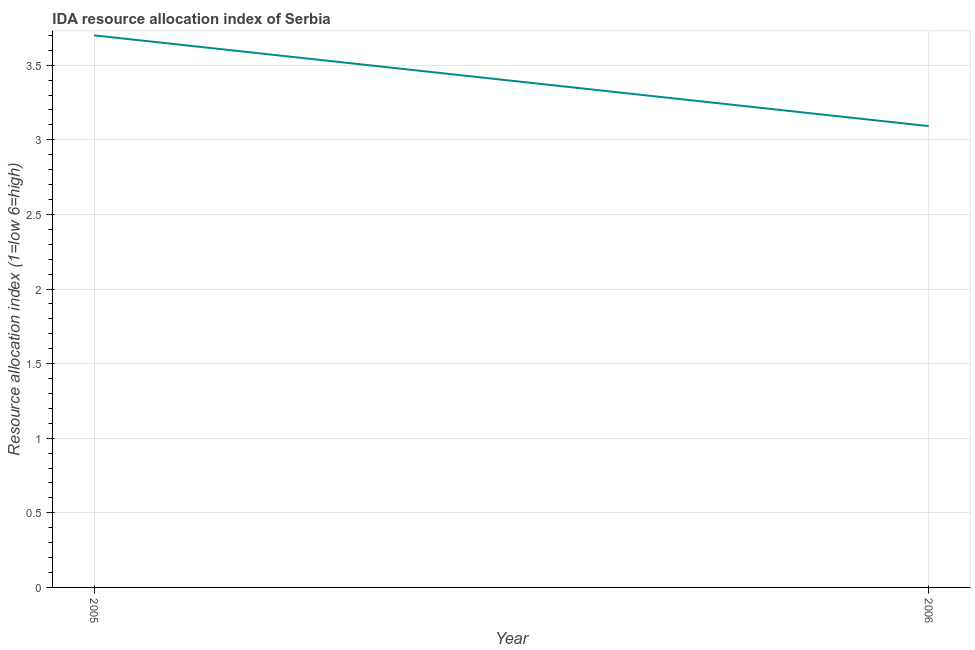What is the ida resource allocation index in 2005?
Provide a succinct answer. 3.7. Across all years, what is the maximum ida resource allocation index?
Give a very brief answer. 3.7. Across all years, what is the minimum ida resource allocation index?
Offer a terse response. 3.09. In which year was the ida resource allocation index maximum?
Provide a succinct answer. 2005. In which year was the ida resource allocation index minimum?
Offer a very short reply. 2006. What is the sum of the ida resource allocation index?
Your response must be concise. 6.79. What is the difference between the ida resource allocation index in 2005 and 2006?
Ensure brevity in your answer.  0.61. What is the average ida resource allocation index per year?
Offer a terse response. 3.4. What is the median ida resource allocation index?
Your answer should be very brief. 3.4. Do a majority of the years between 2006 and 2005 (inclusive) have ida resource allocation index greater than 1.9 ?
Provide a short and direct response. No. What is the ratio of the ida resource allocation index in 2005 to that in 2006?
Your answer should be compact. 1.2. Is the ida resource allocation index in 2005 less than that in 2006?
Make the answer very short. No. In how many years, is the ida resource allocation index greater than the average ida resource allocation index taken over all years?
Ensure brevity in your answer.  1. Does the ida resource allocation index monotonically increase over the years?
Your answer should be compact. No. What is the difference between two consecutive major ticks on the Y-axis?
Offer a terse response. 0.5. Are the values on the major ticks of Y-axis written in scientific E-notation?
Offer a terse response. No. Does the graph contain any zero values?
Keep it short and to the point. No. What is the title of the graph?
Your answer should be compact. IDA resource allocation index of Serbia. What is the label or title of the X-axis?
Provide a succinct answer. Year. What is the label or title of the Y-axis?
Give a very brief answer. Resource allocation index (1=low 6=high). What is the Resource allocation index (1=low 6=high) of 2006?
Your answer should be very brief. 3.09. What is the difference between the Resource allocation index (1=low 6=high) in 2005 and 2006?
Give a very brief answer. 0.61. What is the ratio of the Resource allocation index (1=low 6=high) in 2005 to that in 2006?
Offer a very short reply. 1.2. 